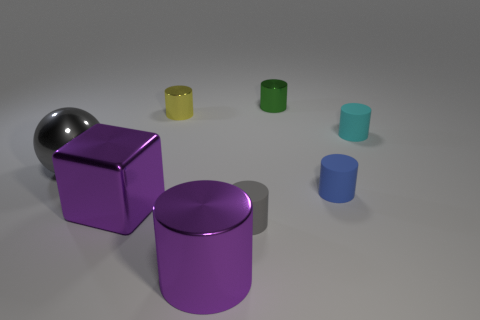Subtract all tiny metal cylinders. How many cylinders are left? 4 Add 2 cyan rubber cylinders. How many objects exist? 10 Subtract all green cylinders. How many cylinders are left? 5 Subtract 4 cylinders. How many cylinders are left? 2 Subtract all red cylinders. Subtract all purple blocks. How many cylinders are left? 6 Subtract all cubes. How many objects are left? 7 Subtract all small gray metallic objects. Subtract all big purple cubes. How many objects are left? 7 Add 3 big purple shiny things. How many big purple shiny things are left? 5 Add 8 tiny green metal cylinders. How many tiny green metal cylinders exist? 9 Subtract 1 cyan cylinders. How many objects are left? 7 